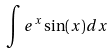Convert formula to latex. <formula><loc_0><loc_0><loc_500><loc_500>\int e ^ { x } \sin ( x ) d x</formula> 